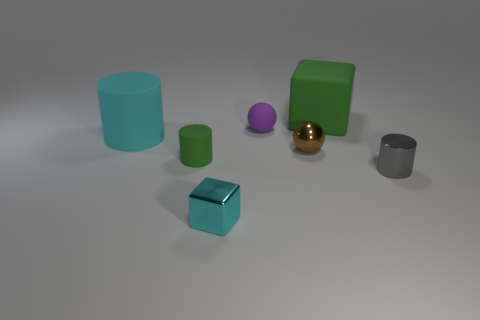Subtract all small metal cylinders. How many cylinders are left? 2 Subtract all gray cylinders. How many cylinders are left? 2 Add 2 cyan matte objects. How many objects exist? 9 Add 5 tiny green matte things. How many tiny green matte things exist? 6 Subtract 0 red cylinders. How many objects are left? 7 Subtract all blocks. How many objects are left? 5 Subtract 1 cylinders. How many cylinders are left? 2 Subtract all purple cylinders. Subtract all red balls. How many cylinders are left? 3 Subtract all blue cubes. How many yellow cylinders are left? 0 Subtract all tiny yellow spheres. Subtract all large cubes. How many objects are left? 6 